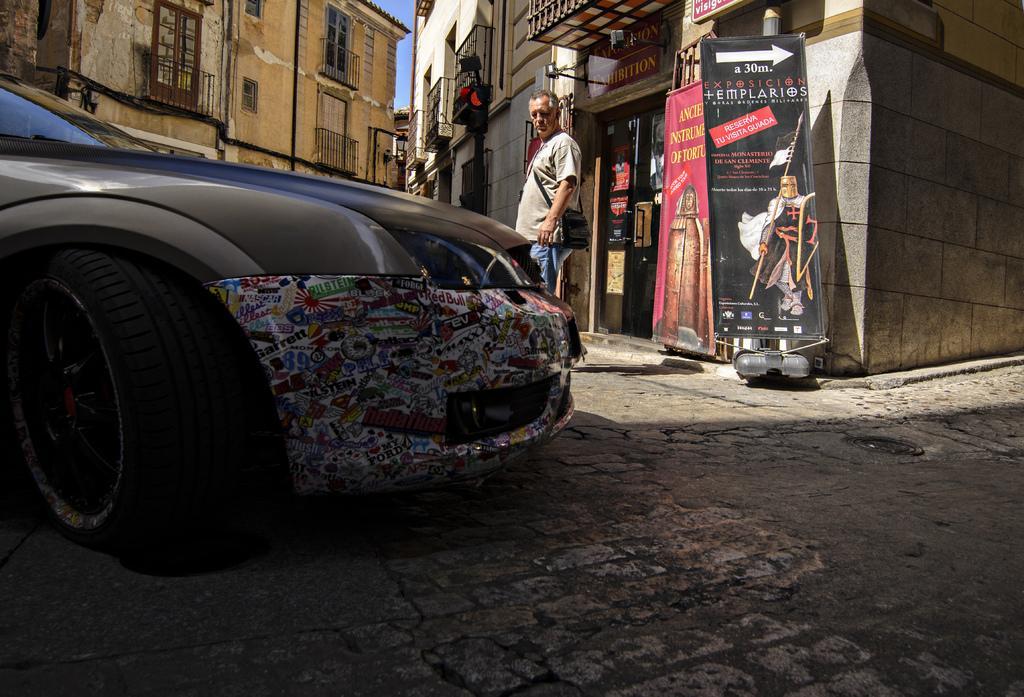Can you describe this image briefly? In front of the image there is a car, behind the car there is a person standing, behind the person there are banners and display boards in front of the shop with glass door, on the door there are posters attached. In the background of the image there are traffic lights and buildings. 